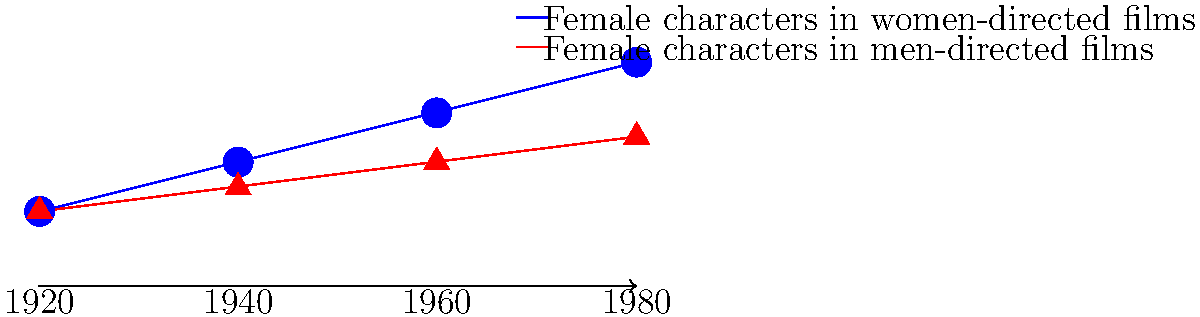Analyze the evolution of female characters in classic Hollywood cinema from 1920 to 1980, as depicted in the timeline. What significant trend does the graph reveal about the portrayal of women in films directed by female filmmakers compared to those directed by men, and how might this relate to the changing societal roles of women during this period? To answer this question, we need to analyze the graph and consider the historical context:

1. Interpretation of the graph:
   - The blue line represents female characters in women-directed films.
   - The red line represents female characters in men-directed films.
   - The y-axis implies the complexity or depth of female characters.
   - The x-axis shows the timeline from 1920 to 1980.

2. Trend analysis:
   - Both lines show an upward trend, indicating improvement in female character portrayals over time.
   - The blue line (women-directed films) shows a steeper incline compared to the red line (men-directed films).
   - By 1980, there's a significant gap between the two lines, with women-directed films showing more complex female characters.

3. Historical context:
   - 1920s: Women's suffrage movement gains momentum.
   - 1940s: World War II leads to more women in the workforce.
   - 1960s-1970s: Second-wave feminism emerges, pushing for greater equality.

4. Correlation with societal changes:
   - The gradual improvement in female character portrayal aligns with women's increasing societal roles.
   - The more pronounced improvement in women-directed films suggests female filmmakers were more responsive to these societal changes.

5. Significance in classic Hollywood:
   - Despite the male-dominated industry, women directors consistently portrayed more complex female characters.
   - This trend challenges the traditional narratives often associated with classic Hollywood cinema.

The graph reveals that female filmmakers in classic Hollywood consistently portrayed more complex and nuanced female characters compared to their male counterparts, with this difference becoming more pronounced over time. This trend likely reflects the changing societal roles of women and the unique perspective that female directors brought to their work.
Answer: Female directors consistently portrayed more complex female characters than male directors, with the gap widening over time, reflecting changing societal roles of women. 